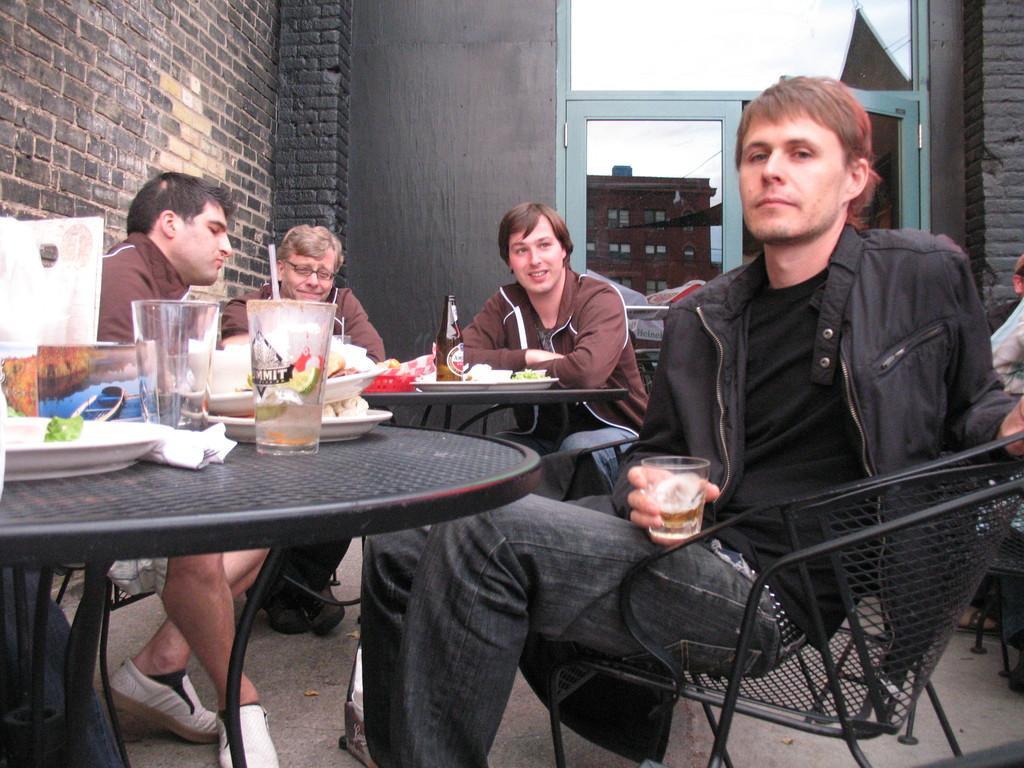In one or two sentences, can you explain what this image depicts? In there image there is a man sat on chair holding a beer glass in front of him there is a table and background him there are few men sat on chair with beer bottle,it seems to be a bar area. 